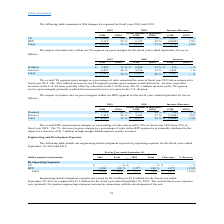According to Csp's financial document, When is the company's financial year end? According to the financial document, September 30. The relevant text states: "gment on gross margins for the fiscal years ended September 30 was as..." Also, How many product mixes does the company have? According to the financial document, 2. The relevant text states: "2019 2018 Increase (Decrease)..." Also, What is the company's total gross margin in 2019? According to the financial document, $13,889 (in thousands). The relevant text states: "TS $ 13,889 20 % $ 12,262 20 % $ 1,627 — %..." Also, can you calculate: What is the company's total revenue in 2019? Based on the calculation: $13,889/20% , the result is 69445 (in thousands). This is based on the information: "summarizes GM changes by segment for fiscal years 2019 and 2018: TS $ 13,889 20 % $ 12,262 20 % $ 1,627 — %..." The key data points involved are: 13,889, 20. Also, can you calculate: What percentage of the company's total gross margin arises from products? Based on the calculation: $7,462/$13,889 , the result is 53.73 (percentage). This is based on the information: "TS $ 13,889 20 % $ 12,262 20 % $ 1,627 — % Products $ 7,462 13 % $ 6,886 13 % $ 576 — %..." The key data points involved are: 13,889, 7,462. Also, can you calculate: What is the percentage change in gross margins from services between 2018 and 2019? To answer this question, I need to perform calculations using the financial data. The calculation is: (6,427 - 5,376)/5,376 , which equals 19.55 (percentage). This is based on the information: "Services 6,427 56 % 5,376 55 % 1,051 1 % Services 6,427 56 % 5,376 55 % 1,051 1 %..." The key data points involved are: 5,376, 6,427. 